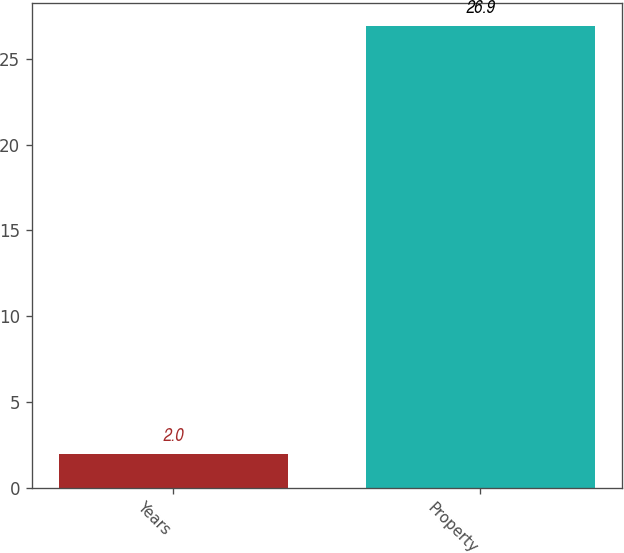Convert chart. <chart><loc_0><loc_0><loc_500><loc_500><bar_chart><fcel>Years<fcel>Property<nl><fcel>2<fcel>26.9<nl></chart> 